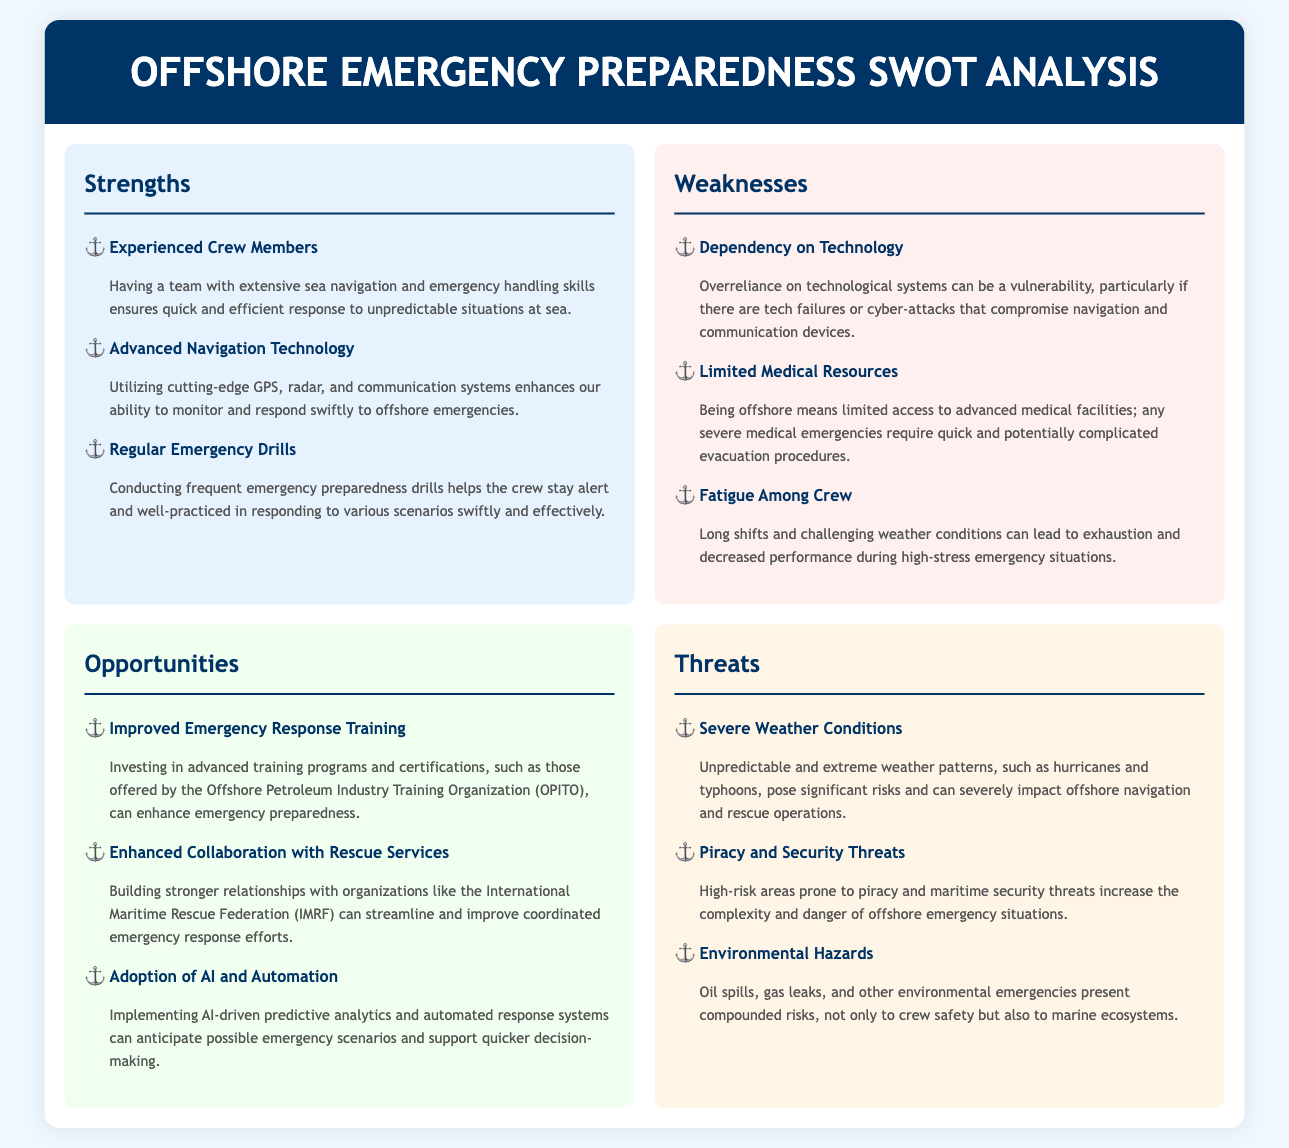what are the strengths mentioned in the document? The document lists three strengths: Experienced Crew Members, Advanced Navigation Technology, and Regular Emergency Drills.
Answer: Experienced Crew Members, Advanced Navigation Technology, Regular Emergency Drills what is one of the weaknesses related to technology? The document states that "overreliance on technological systems can be a vulnerability," highlighting tech failures or cyber-attacks.
Answer: Dependency on Technology what are the opportunities for improvement? The document mentions three opportunities: Improved Emergency Response Training, Enhanced Collaboration with Rescue Services, and Adoption of AI and Automation.
Answer: Improved Emergency Response Training, Enhanced Collaboration with Rescue Services, Adoption of AI and Automation what is a significant threat mentioned in the SWOT analysis? The document lists three threats, including Severe Weather Conditions, Piracy and Security Threats, and Environmental Hazards.
Answer: Severe Weather Conditions how does regular emergency drills benefit the crew? Regular drills ensure the crew stays alert and well-practiced in responding to various scenarios swiftly and effectively.
Answer: Quick and efficient response which organization is mentioned under opportunities for collaboration? The document refers to the International Maritime Rescue Federation (IMRF) as an opportunity for enhanced collaboration.
Answer: International Maritime Rescue Federation (IMRF) what impacts can environmental hazards have on crew safety? The document states that environmental hazards not only present risks to crew safety but also to marine ecosystems.
Answer: Risks to crew safety and marine ecosystems what can advanced training programs improve according to the document? The document suggests that advanced training programs can enhance emergency preparedness in offshore emergency situations.
Answer: Emergency preparedness 